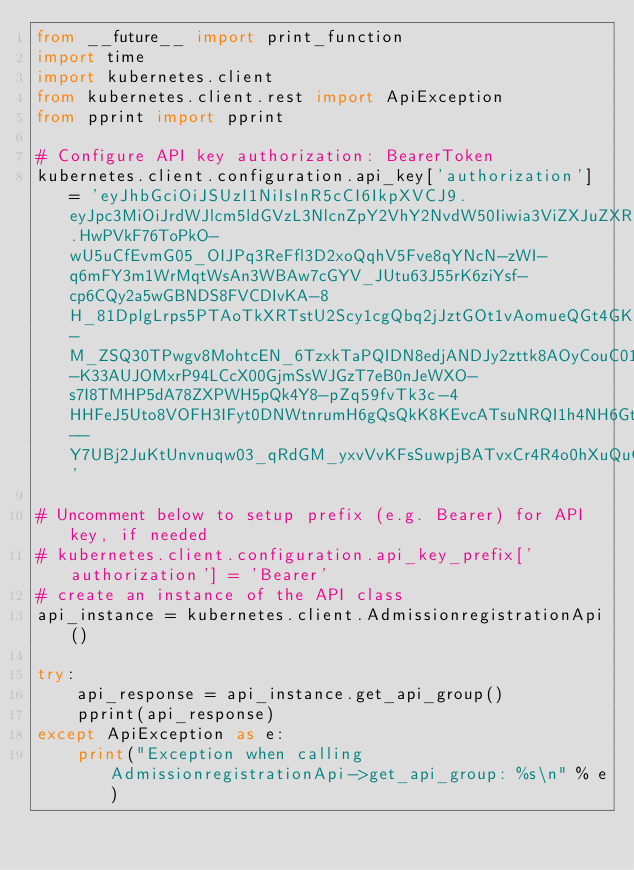<code> <loc_0><loc_0><loc_500><loc_500><_Python_>from __future__ import print_function
import time
import kubernetes.client
from kubernetes.client.rest import ApiException
from pprint import pprint

# Configure API key authorization: BearerToken
kubernetes.client.configuration.api_key['authorization'] = 'eyJhbGciOiJSUzI1NiIsInR5cCI6IkpXVCJ9.eyJpc3MiOiJrdWJlcm5ldGVzL3NlcnZpY2VhY2NvdW50Iiwia3ViZXJuZXRlcy5pby9zZXJ2aWNlYWNjb3VudC9uYW1lc3BhY2UiOiJkZWZhdWx0Iiwia3ViZXJuZXRlcy5pby9zZXJ2aWNlYWNjb3VudC9zZWNyZXQubmFtZSI6InRlc3RhYy10b2tlbi12bHZtcyIsImt1YmVybmV0ZXMuaW8vc2VydmljZWFjY291bnQvc2VydmljZS1hY2NvdW50Lm5hbWUiOiJ0ZXN0YWMiLCJrdWJlcm5ldGVzLmlvL3NlcnZpY2VhY2NvdW50L3NlcnZpY2UtYWNjb3VudC51aWQiOiJiYTkyYWM5Mi03MGU4LTExZTgtOThiMS0wMjk3NmQxOTU4ZjgiLCJzdWIiOiJzeXN0ZW06c2VydmljZWFjY291bnQ6ZGVmYXVsdDp0ZXN0YWMifQ.HwPVkF76ToPkO-wU5uCfEvmG05_OIJPq3ReFfl3D2xoQqhV5Fve8qYNcN-zWI-q6mFY3m1WrMqtWsAn3WBAw7cGYV_JUtu63J55rK6ziYsf-cp6CQy2a5wGBNDS8FVCDIvKA-8H_81DplgLrps5PTAoTkXRTstU2Scy1cgQbq2jJztGOt1vAomueQGt4GKeK3vPH4s8iOvruSkiQ96U5-M_ZSQ30TPwgv8MohtcEN_6TzxkTaPQIDN8edjANDJy2zttk8AOyCouC01iJvPVd9FFG3thH4AYFQ3shVzviD8hS2Cyh6RDGulFXIFm3aZ7QR8KAU1BjAGO7KBGdUmoMIGXzrNsZzm-K33AUJOMxrP94LCcX00GjmSsWJGzT7eB0nJeWXO-s7I8TMHP5dA78ZXPWH5pQk4Y8-pZq59fvTk3c-4HHFeJ5Uto8VOFH3IFyt0DNWtnrumH6gQsQkK8KEvcATsuNRQI1h4NH6GtATg8OPR8LXuG6Tm9fGUip3AdVxQ9t6P2AhSyJ3b4_W2pZ8V75FT_Y6wXptEVdNURyXKNE9SPgUxTLJlJJbAFSXcvonKdRNBD7JfZATsBKInC3fnoTJkHIUAw1aG7Ql--Y7UBj2JuKtUnvnuqw03_qRdGM_yxvVvKFsSuwpjBATvxCr4R4o0hXuQuGlrJX9SWFz0o'

# Uncomment below to setup prefix (e.g. Bearer) for API key, if needed
# kubernetes.client.configuration.api_key_prefix['authorization'] = 'Bearer'
# create an instance of the API class
api_instance = kubernetes.client.AdmissionregistrationApi()

try:
    api_response = api_instance.get_api_group()
    pprint(api_response)
except ApiException as e:
    print("Exception when calling AdmissionregistrationApi->get_api_group: %s\n" % e)
</code> 